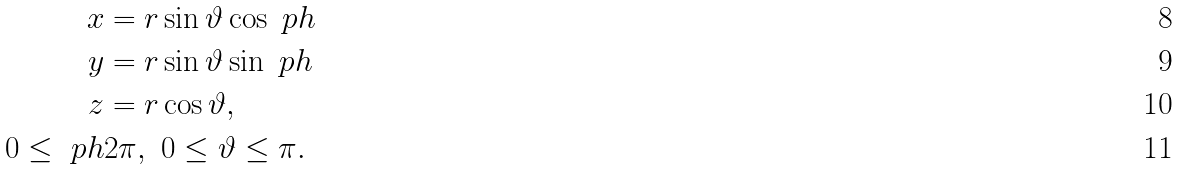Convert formula to latex. <formula><loc_0><loc_0><loc_500><loc_500>x & = r \sin \vartheta \cos \ p h \\ y & = r \sin \vartheta \sin \ p h \\ z & = r \cos \vartheta , \\ 0 \leq \ p h & 2 \pi , \ 0 \leq \vartheta \leq \pi .</formula> 